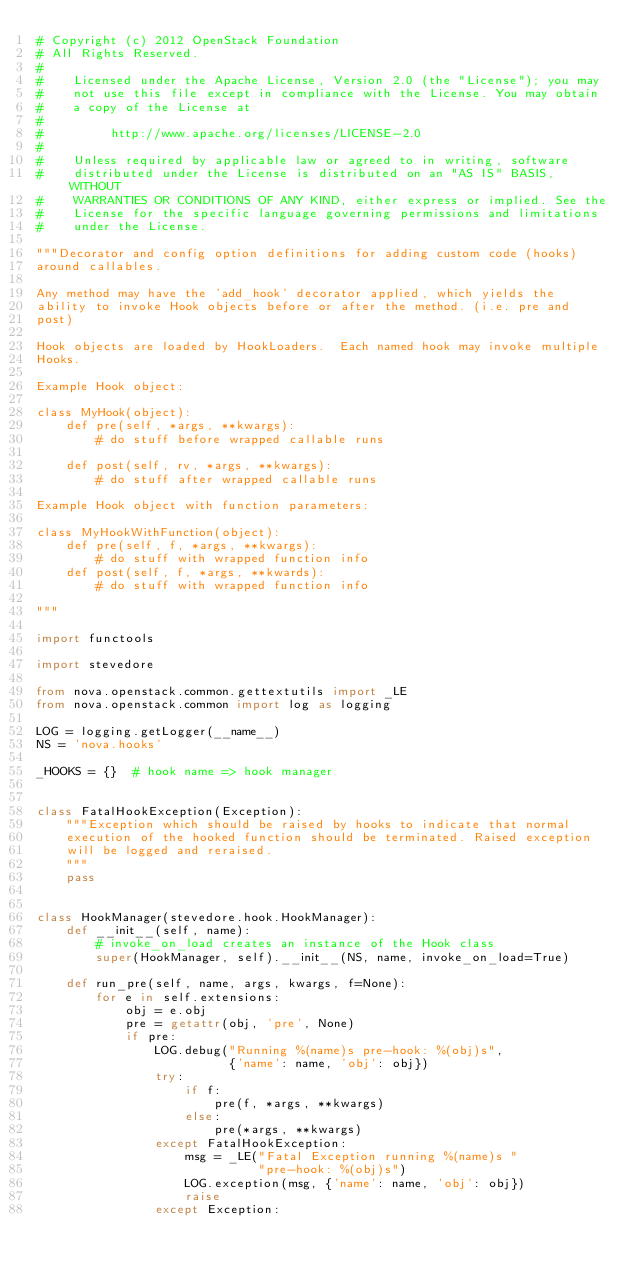Convert code to text. <code><loc_0><loc_0><loc_500><loc_500><_Python_># Copyright (c) 2012 OpenStack Foundation
# All Rights Reserved.
#
#    Licensed under the Apache License, Version 2.0 (the "License"); you may
#    not use this file except in compliance with the License. You may obtain
#    a copy of the License at
#
#         http://www.apache.org/licenses/LICENSE-2.0
#
#    Unless required by applicable law or agreed to in writing, software
#    distributed under the License is distributed on an "AS IS" BASIS, WITHOUT
#    WARRANTIES OR CONDITIONS OF ANY KIND, either express or implied. See the
#    License for the specific language governing permissions and limitations
#    under the License.

"""Decorator and config option definitions for adding custom code (hooks)
around callables.

Any method may have the 'add_hook' decorator applied, which yields the
ability to invoke Hook objects before or after the method. (i.e. pre and
post)

Hook objects are loaded by HookLoaders.  Each named hook may invoke multiple
Hooks.

Example Hook object:

class MyHook(object):
    def pre(self, *args, **kwargs):
        # do stuff before wrapped callable runs

    def post(self, rv, *args, **kwargs):
        # do stuff after wrapped callable runs

Example Hook object with function parameters:

class MyHookWithFunction(object):
    def pre(self, f, *args, **kwargs):
        # do stuff with wrapped function info
    def post(self, f, *args, **kwards):
        # do stuff with wrapped function info

"""

import functools

import stevedore

from nova.openstack.common.gettextutils import _LE
from nova.openstack.common import log as logging

LOG = logging.getLogger(__name__)
NS = 'nova.hooks'

_HOOKS = {}  # hook name => hook manager


class FatalHookException(Exception):
    """Exception which should be raised by hooks to indicate that normal
    execution of the hooked function should be terminated. Raised exception
    will be logged and reraised.
    """
    pass


class HookManager(stevedore.hook.HookManager):
    def __init__(self, name):
        # invoke_on_load creates an instance of the Hook class
        super(HookManager, self).__init__(NS, name, invoke_on_load=True)

    def run_pre(self, name, args, kwargs, f=None):
        for e in self.extensions:
            obj = e.obj
            pre = getattr(obj, 'pre', None)
            if pre:
                LOG.debug("Running %(name)s pre-hook: %(obj)s",
                          {'name': name, 'obj': obj})
                try:
                    if f:
                        pre(f, *args, **kwargs)
                    else:
                        pre(*args, **kwargs)
                except FatalHookException:
                    msg = _LE("Fatal Exception running %(name)s "
                              "pre-hook: %(obj)s")
                    LOG.exception(msg, {'name': name, 'obj': obj})
                    raise
                except Exception:</code> 